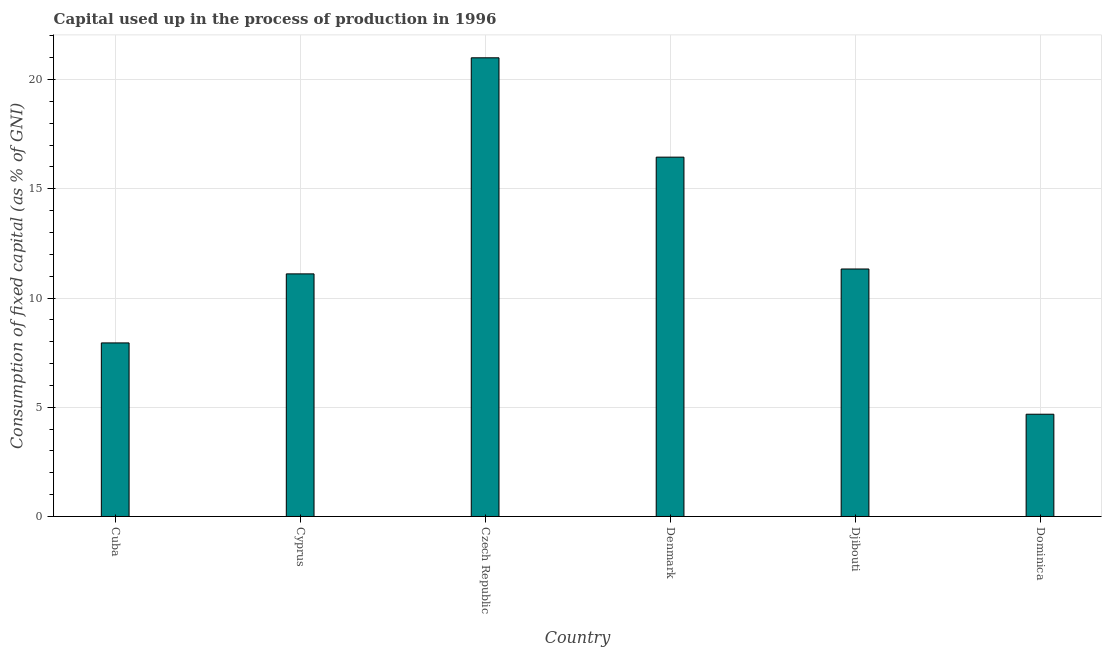What is the title of the graph?
Your answer should be very brief. Capital used up in the process of production in 1996. What is the label or title of the X-axis?
Provide a succinct answer. Country. What is the label or title of the Y-axis?
Offer a terse response. Consumption of fixed capital (as % of GNI). What is the consumption of fixed capital in Dominica?
Keep it short and to the point. 4.68. Across all countries, what is the maximum consumption of fixed capital?
Make the answer very short. 21. Across all countries, what is the minimum consumption of fixed capital?
Your answer should be very brief. 4.68. In which country was the consumption of fixed capital maximum?
Provide a succinct answer. Czech Republic. In which country was the consumption of fixed capital minimum?
Your answer should be very brief. Dominica. What is the sum of the consumption of fixed capital?
Your answer should be compact. 72.51. What is the difference between the consumption of fixed capital in Cuba and Denmark?
Give a very brief answer. -8.5. What is the average consumption of fixed capital per country?
Keep it short and to the point. 12.09. What is the median consumption of fixed capital?
Provide a short and direct response. 11.22. What is the ratio of the consumption of fixed capital in Djibouti to that in Dominica?
Provide a short and direct response. 2.42. Is the difference between the consumption of fixed capital in Cuba and Czech Republic greater than the difference between any two countries?
Offer a terse response. No. What is the difference between the highest and the second highest consumption of fixed capital?
Provide a succinct answer. 4.55. What is the difference between the highest and the lowest consumption of fixed capital?
Offer a very short reply. 16.32. How many bars are there?
Make the answer very short. 6. How many countries are there in the graph?
Provide a succinct answer. 6. What is the difference between two consecutive major ticks on the Y-axis?
Give a very brief answer. 5. Are the values on the major ticks of Y-axis written in scientific E-notation?
Your response must be concise. No. What is the Consumption of fixed capital (as % of GNI) in Cuba?
Your response must be concise. 7.95. What is the Consumption of fixed capital (as % of GNI) of Cyprus?
Make the answer very short. 11.11. What is the Consumption of fixed capital (as % of GNI) in Czech Republic?
Your answer should be compact. 21. What is the Consumption of fixed capital (as % of GNI) in Denmark?
Provide a short and direct response. 16.45. What is the Consumption of fixed capital (as % of GNI) of Djibouti?
Keep it short and to the point. 11.33. What is the Consumption of fixed capital (as % of GNI) of Dominica?
Your answer should be very brief. 4.68. What is the difference between the Consumption of fixed capital (as % of GNI) in Cuba and Cyprus?
Provide a short and direct response. -3.16. What is the difference between the Consumption of fixed capital (as % of GNI) in Cuba and Czech Republic?
Your answer should be very brief. -13.05. What is the difference between the Consumption of fixed capital (as % of GNI) in Cuba and Denmark?
Provide a short and direct response. -8.5. What is the difference between the Consumption of fixed capital (as % of GNI) in Cuba and Djibouti?
Provide a short and direct response. -3.38. What is the difference between the Consumption of fixed capital (as % of GNI) in Cuba and Dominica?
Offer a terse response. 3.26. What is the difference between the Consumption of fixed capital (as % of GNI) in Cyprus and Czech Republic?
Keep it short and to the point. -9.89. What is the difference between the Consumption of fixed capital (as % of GNI) in Cyprus and Denmark?
Your response must be concise. -5.34. What is the difference between the Consumption of fixed capital (as % of GNI) in Cyprus and Djibouti?
Offer a very short reply. -0.22. What is the difference between the Consumption of fixed capital (as % of GNI) in Cyprus and Dominica?
Make the answer very short. 6.42. What is the difference between the Consumption of fixed capital (as % of GNI) in Czech Republic and Denmark?
Your response must be concise. 4.55. What is the difference between the Consumption of fixed capital (as % of GNI) in Czech Republic and Djibouti?
Keep it short and to the point. 9.67. What is the difference between the Consumption of fixed capital (as % of GNI) in Czech Republic and Dominica?
Your answer should be compact. 16.32. What is the difference between the Consumption of fixed capital (as % of GNI) in Denmark and Djibouti?
Provide a short and direct response. 5.12. What is the difference between the Consumption of fixed capital (as % of GNI) in Denmark and Dominica?
Offer a very short reply. 11.77. What is the difference between the Consumption of fixed capital (as % of GNI) in Djibouti and Dominica?
Make the answer very short. 6.65. What is the ratio of the Consumption of fixed capital (as % of GNI) in Cuba to that in Cyprus?
Your answer should be very brief. 0.71. What is the ratio of the Consumption of fixed capital (as % of GNI) in Cuba to that in Czech Republic?
Ensure brevity in your answer.  0.38. What is the ratio of the Consumption of fixed capital (as % of GNI) in Cuba to that in Denmark?
Make the answer very short. 0.48. What is the ratio of the Consumption of fixed capital (as % of GNI) in Cuba to that in Djibouti?
Give a very brief answer. 0.7. What is the ratio of the Consumption of fixed capital (as % of GNI) in Cuba to that in Dominica?
Ensure brevity in your answer.  1.7. What is the ratio of the Consumption of fixed capital (as % of GNI) in Cyprus to that in Czech Republic?
Provide a succinct answer. 0.53. What is the ratio of the Consumption of fixed capital (as % of GNI) in Cyprus to that in Denmark?
Provide a short and direct response. 0.68. What is the ratio of the Consumption of fixed capital (as % of GNI) in Cyprus to that in Djibouti?
Offer a terse response. 0.98. What is the ratio of the Consumption of fixed capital (as % of GNI) in Cyprus to that in Dominica?
Offer a very short reply. 2.37. What is the ratio of the Consumption of fixed capital (as % of GNI) in Czech Republic to that in Denmark?
Your answer should be compact. 1.28. What is the ratio of the Consumption of fixed capital (as % of GNI) in Czech Republic to that in Djibouti?
Your response must be concise. 1.85. What is the ratio of the Consumption of fixed capital (as % of GNI) in Czech Republic to that in Dominica?
Give a very brief answer. 4.49. What is the ratio of the Consumption of fixed capital (as % of GNI) in Denmark to that in Djibouti?
Ensure brevity in your answer.  1.45. What is the ratio of the Consumption of fixed capital (as % of GNI) in Denmark to that in Dominica?
Offer a very short reply. 3.51. What is the ratio of the Consumption of fixed capital (as % of GNI) in Djibouti to that in Dominica?
Your answer should be compact. 2.42. 